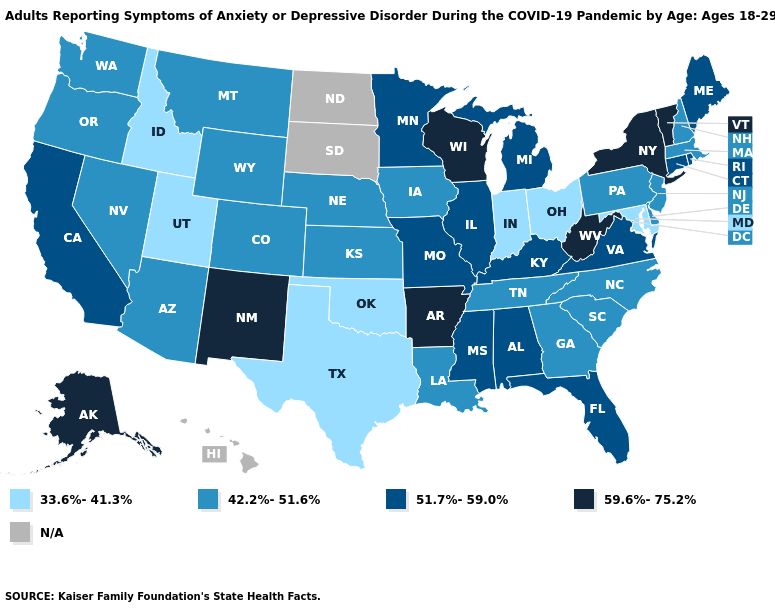Name the states that have a value in the range 33.6%-41.3%?
Be succinct. Idaho, Indiana, Maryland, Ohio, Oklahoma, Texas, Utah. Which states have the lowest value in the West?
Write a very short answer. Idaho, Utah. Which states have the highest value in the USA?
Be succinct. Alaska, Arkansas, New Mexico, New York, Vermont, West Virginia, Wisconsin. Which states hav the highest value in the South?
Write a very short answer. Arkansas, West Virginia. Does Idaho have the lowest value in the USA?
Give a very brief answer. Yes. Is the legend a continuous bar?
Quick response, please. No. Name the states that have a value in the range 42.2%-51.6%?
Give a very brief answer. Arizona, Colorado, Delaware, Georgia, Iowa, Kansas, Louisiana, Massachusetts, Montana, Nebraska, Nevada, New Hampshire, New Jersey, North Carolina, Oregon, Pennsylvania, South Carolina, Tennessee, Washington, Wyoming. Does Indiana have the highest value in the MidWest?
Short answer required. No. Is the legend a continuous bar?
Give a very brief answer. No. Name the states that have a value in the range N/A?
Keep it brief. Hawaii, North Dakota, South Dakota. Is the legend a continuous bar?
Answer briefly. No. Does the map have missing data?
Give a very brief answer. Yes. Does Michigan have the lowest value in the MidWest?
Give a very brief answer. No. 